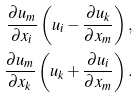Convert formula to latex. <formula><loc_0><loc_0><loc_500><loc_500>\frac { \partial u _ { m } } { \partial x _ { i } } \left ( u _ { i } - \frac { \partial u _ { k } } { \partial x _ { m } } \right ) , \\ \frac { \partial u _ { m } } { \partial x _ { k } } \left ( u _ { k } + \frac { \partial u _ { i } } { \partial x _ { m } } \right ) .</formula> 